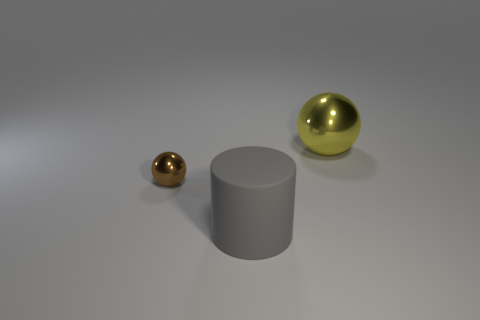Is there any other thing that is made of the same material as the large gray cylinder?
Keep it short and to the point. No. What is the material of the big yellow thing that is the same shape as the tiny brown thing?
Your response must be concise. Metal. There is a ball that is left of the big yellow shiny ball that is behind the metallic thing left of the yellow sphere; what size is it?
Give a very brief answer. Small. Is the size of the brown sphere the same as the yellow shiny object?
Your answer should be compact. No. The large thing in front of the object on the right side of the gray object is made of what material?
Provide a short and direct response. Rubber. There is a metallic object in front of the yellow sphere; is it the same shape as the big object that is to the right of the rubber thing?
Provide a short and direct response. Yes. Is the number of cylinders that are behind the tiny brown ball the same as the number of big gray cylinders?
Make the answer very short. No. There is a metal object to the right of the large gray rubber object; are there any big yellow metallic objects in front of it?
Offer a terse response. No. Are there any other things that have the same color as the large rubber cylinder?
Give a very brief answer. No. Are the large thing that is in front of the brown sphere and the large yellow object made of the same material?
Your response must be concise. No. 